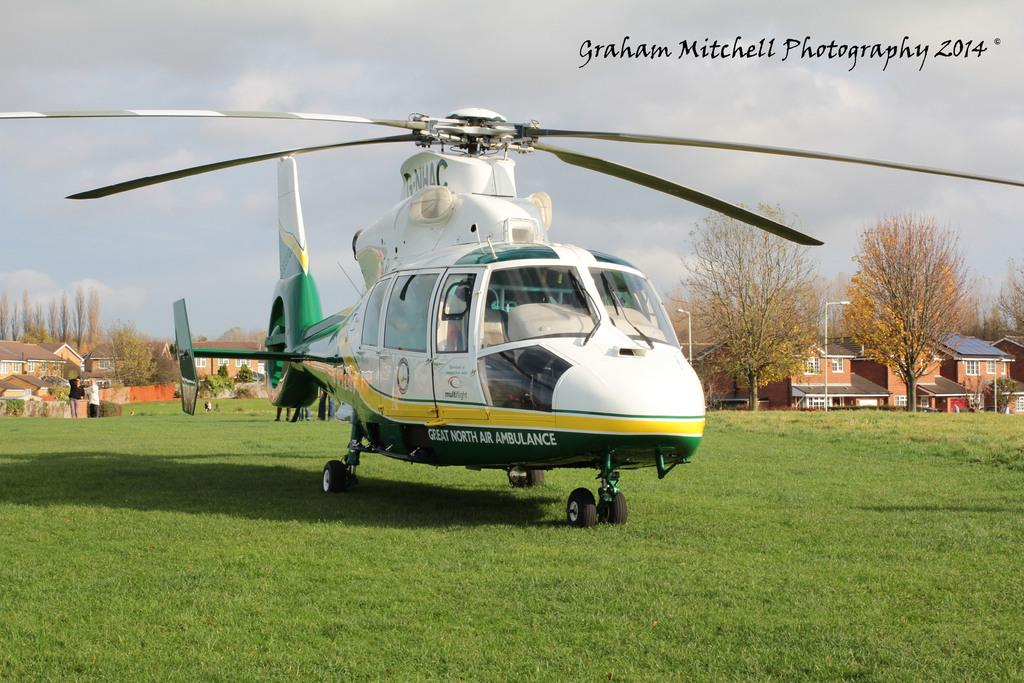What is the main subject of the image? The main subject of the image is a helicopter. Where is the helicopter located in the image? The helicopter is on the surface of green land. What can be seen in the background of the image? There are buildings and trees in the background of the image. How would you describe the sky in the image? The sky is full of clouds. Can you tell me how many ants are crawling on the helicopter in the image? There are no ants present in the image; the main subject is a helicopter on green land with a cloudy sky and buildings and trees in the background. 